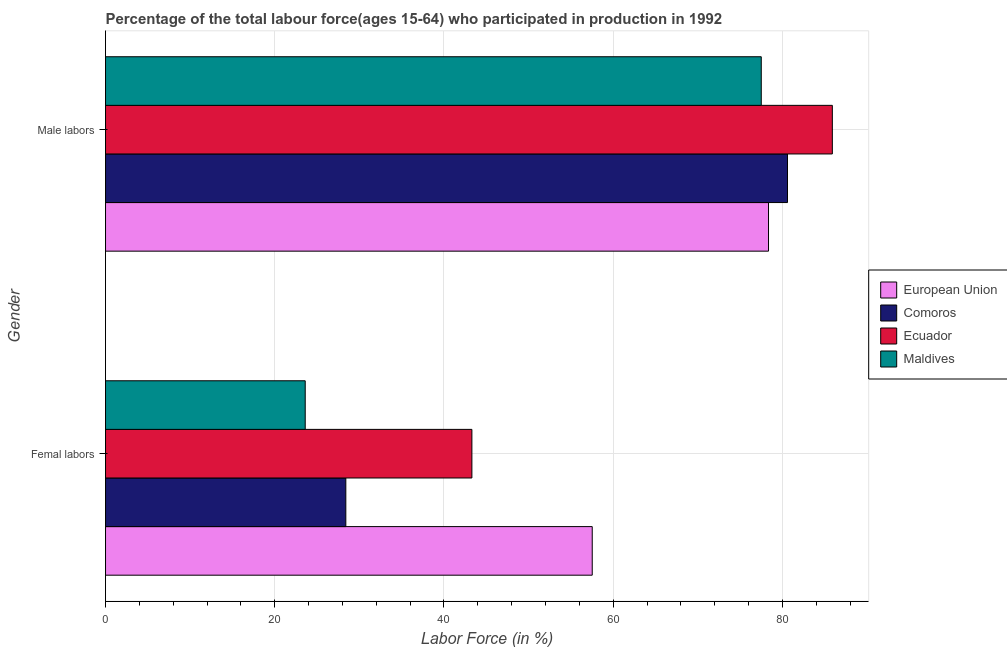How many groups of bars are there?
Make the answer very short. 2. Are the number of bars per tick equal to the number of legend labels?
Keep it short and to the point. Yes. How many bars are there on the 1st tick from the top?
Provide a succinct answer. 4. What is the label of the 1st group of bars from the top?
Ensure brevity in your answer.  Male labors. What is the percentage of female labor force in Comoros?
Your answer should be very brief. 28.4. Across all countries, what is the maximum percentage of female labor force?
Offer a terse response. 57.52. Across all countries, what is the minimum percentage of male labour force?
Keep it short and to the point. 77.5. In which country was the percentage of male labour force maximum?
Provide a succinct answer. Ecuador. In which country was the percentage of male labour force minimum?
Ensure brevity in your answer.  Maldives. What is the total percentage of female labor force in the graph?
Keep it short and to the point. 152.82. What is the difference between the percentage of female labor force in European Union and that in Maldives?
Give a very brief answer. 33.92. What is the difference between the percentage of male labour force in Maldives and the percentage of female labor force in Comoros?
Offer a very short reply. 49.1. What is the average percentage of male labour force per country?
Offer a terse response. 80.59. What is the difference between the percentage of female labor force and percentage of male labour force in Ecuador?
Make the answer very short. -42.6. What is the ratio of the percentage of male labour force in Comoros to that in Maldives?
Give a very brief answer. 1.04. Is the percentage of male labour force in Comoros less than that in Maldives?
Offer a terse response. No. What does the 2nd bar from the top in Male labors represents?
Keep it short and to the point. Ecuador. What does the 1st bar from the bottom in Femal labors represents?
Provide a short and direct response. European Union. Are all the bars in the graph horizontal?
Keep it short and to the point. Yes. What is the difference between two consecutive major ticks on the X-axis?
Provide a succinct answer. 20. Are the values on the major ticks of X-axis written in scientific E-notation?
Make the answer very short. No. Where does the legend appear in the graph?
Provide a succinct answer. Center right. How many legend labels are there?
Ensure brevity in your answer.  4. How are the legend labels stacked?
Your answer should be compact. Vertical. What is the title of the graph?
Ensure brevity in your answer.  Percentage of the total labour force(ages 15-64) who participated in production in 1992. Does "Uruguay" appear as one of the legend labels in the graph?
Your answer should be very brief. No. What is the label or title of the X-axis?
Provide a short and direct response. Labor Force (in %). What is the label or title of the Y-axis?
Keep it short and to the point. Gender. What is the Labor Force (in %) of European Union in Femal labors?
Provide a short and direct response. 57.52. What is the Labor Force (in %) of Comoros in Femal labors?
Make the answer very short. 28.4. What is the Labor Force (in %) in Ecuador in Femal labors?
Make the answer very short. 43.3. What is the Labor Force (in %) of Maldives in Femal labors?
Ensure brevity in your answer.  23.6. What is the Labor Force (in %) in European Union in Male labors?
Your answer should be very brief. 78.36. What is the Labor Force (in %) in Comoros in Male labors?
Provide a short and direct response. 80.6. What is the Labor Force (in %) of Ecuador in Male labors?
Provide a short and direct response. 85.9. What is the Labor Force (in %) of Maldives in Male labors?
Ensure brevity in your answer.  77.5. Across all Gender, what is the maximum Labor Force (in %) of European Union?
Keep it short and to the point. 78.36. Across all Gender, what is the maximum Labor Force (in %) of Comoros?
Give a very brief answer. 80.6. Across all Gender, what is the maximum Labor Force (in %) of Ecuador?
Provide a succinct answer. 85.9. Across all Gender, what is the maximum Labor Force (in %) of Maldives?
Your answer should be compact. 77.5. Across all Gender, what is the minimum Labor Force (in %) in European Union?
Your answer should be very brief. 57.52. Across all Gender, what is the minimum Labor Force (in %) in Comoros?
Give a very brief answer. 28.4. Across all Gender, what is the minimum Labor Force (in %) in Ecuador?
Make the answer very short. 43.3. Across all Gender, what is the minimum Labor Force (in %) in Maldives?
Make the answer very short. 23.6. What is the total Labor Force (in %) of European Union in the graph?
Provide a succinct answer. 135.88. What is the total Labor Force (in %) of Comoros in the graph?
Make the answer very short. 109. What is the total Labor Force (in %) in Ecuador in the graph?
Provide a succinct answer. 129.2. What is the total Labor Force (in %) in Maldives in the graph?
Offer a terse response. 101.1. What is the difference between the Labor Force (in %) of European Union in Femal labors and that in Male labors?
Provide a succinct answer. -20.84. What is the difference between the Labor Force (in %) in Comoros in Femal labors and that in Male labors?
Ensure brevity in your answer.  -52.2. What is the difference between the Labor Force (in %) of Ecuador in Femal labors and that in Male labors?
Give a very brief answer. -42.6. What is the difference between the Labor Force (in %) of Maldives in Femal labors and that in Male labors?
Provide a succinct answer. -53.9. What is the difference between the Labor Force (in %) of European Union in Femal labors and the Labor Force (in %) of Comoros in Male labors?
Provide a short and direct response. -23.08. What is the difference between the Labor Force (in %) in European Union in Femal labors and the Labor Force (in %) in Ecuador in Male labors?
Make the answer very short. -28.38. What is the difference between the Labor Force (in %) in European Union in Femal labors and the Labor Force (in %) in Maldives in Male labors?
Offer a terse response. -19.98. What is the difference between the Labor Force (in %) of Comoros in Femal labors and the Labor Force (in %) of Ecuador in Male labors?
Offer a very short reply. -57.5. What is the difference between the Labor Force (in %) of Comoros in Femal labors and the Labor Force (in %) of Maldives in Male labors?
Your response must be concise. -49.1. What is the difference between the Labor Force (in %) in Ecuador in Femal labors and the Labor Force (in %) in Maldives in Male labors?
Ensure brevity in your answer.  -34.2. What is the average Labor Force (in %) of European Union per Gender?
Your answer should be compact. 67.94. What is the average Labor Force (in %) of Comoros per Gender?
Provide a short and direct response. 54.5. What is the average Labor Force (in %) in Ecuador per Gender?
Your answer should be very brief. 64.6. What is the average Labor Force (in %) in Maldives per Gender?
Your answer should be very brief. 50.55. What is the difference between the Labor Force (in %) in European Union and Labor Force (in %) in Comoros in Femal labors?
Make the answer very short. 29.12. What is the difference between the Labor Force (in %) of European Union and Labor Force (in %) of Ecuador in Femal labors?
Provide a succinct answer. 14.22. What is the difference between the Labor Force (in %) in European Union and Labor Force (in %) in Maldives in Femal labors?
Ensure brevity in your answer.  33.92. What is the difference between the Labor Force (in %) of Comoros and Labor Force (in %) of Ecuador in Femal labors?
Your answer should be compact. -14.9. What is the difference between the Labor Force (in %) in Ecuador and Labor Force (in %) in Maldives in Femal labors?
Offer a terse response. 19.7. What is the difference between the Labor Force (in %) of European Union and Labor Force (in %) of Comoros in Male labors?
Ensure brevity in your answer.  -2.24. What is the difference between the Labor Force (in %) of European Union and Labor Force (in %) of Ecuador in Male labors?
Offer a very short reply. -7.54. What is the difference between the Labor Force (in %) in European Union and Labor Force (in %) in Maldives in Male labors?
Ensure brevity in your answer.  0.86. What is the difference between the Labor Force (in %) of Comoros and Labor Force (in %) of Ecuador in Male labors?
Give a very brief answer. -5.3. What is the difference between the Labor Force (in %) in Comoros and Labor Force (in %) in Maldives in Male labors?
Ensure brevity in your answer.  3.1. What is the ratio of the Labor Force (in %) in European Union in Femal labors to that in Male labors?
Your response must be concise. 0.73. What is the ratio of the Labor Force (in %) in Comoros in Femal labors to that in Male labors?
Your answer should be compact. 0.35. What is the ratio of the Labor Force (in %) of Ecuador in Femal labors to that in Male labors?
Provide a succinct answer. 0.5. What is the ratio of the Labor Force (in %) of Maldives in Femal labors to that in Male labors?
Your response must be concise. 0.3. What is the difference between the highest and the second highest Labor Force (in %) of European Union?
Your answer should be very brief. 20.84. What is the difference between the highest and the second highest Labor Force (in %) in Comoros?
Keep it short and to the point. 52.2. What is the difference between the highest and the second highest Labor Force (in %) in Ecuador?
Keep it short and to the point. 42.6. What is the difference between the highest and the second highest Labor Force (in %) of Maldives?
Keep it short and to the point. 53.9. What is the difference between the highest and the lowest Labor Force (in %) of European Union?
Provide a short and direct response. 20.84. What is the difference between the highest and the lowest Labor Force (in %) of Comoros?
Give a very brief answer. 52.2. What is the difference between the highest and the lowest Labor Force (in %) in Ecuador?
Your response must be concise. 42.6. What is the difference between the highest and the lowest Labor Force (in %) in Maldives?
Give a very brief answer. 53.9. 